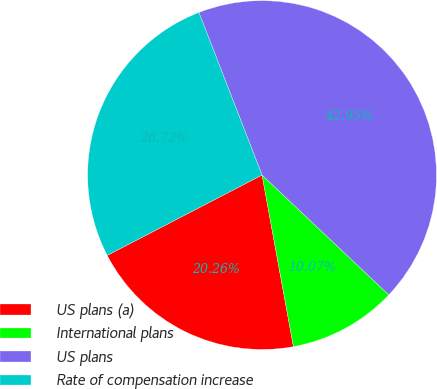Convert chart. <chart><loc_0><loc_0><loc_500><loc_500><pie_chart><fcel>US plans (a)<fcel>International plans<fcel>US plans<fcel>Rate of compensation increase<nl><fcel>20.26%<fcel>10.07%<fcel>42.95%<fcel>26.72%<nl></chart> 